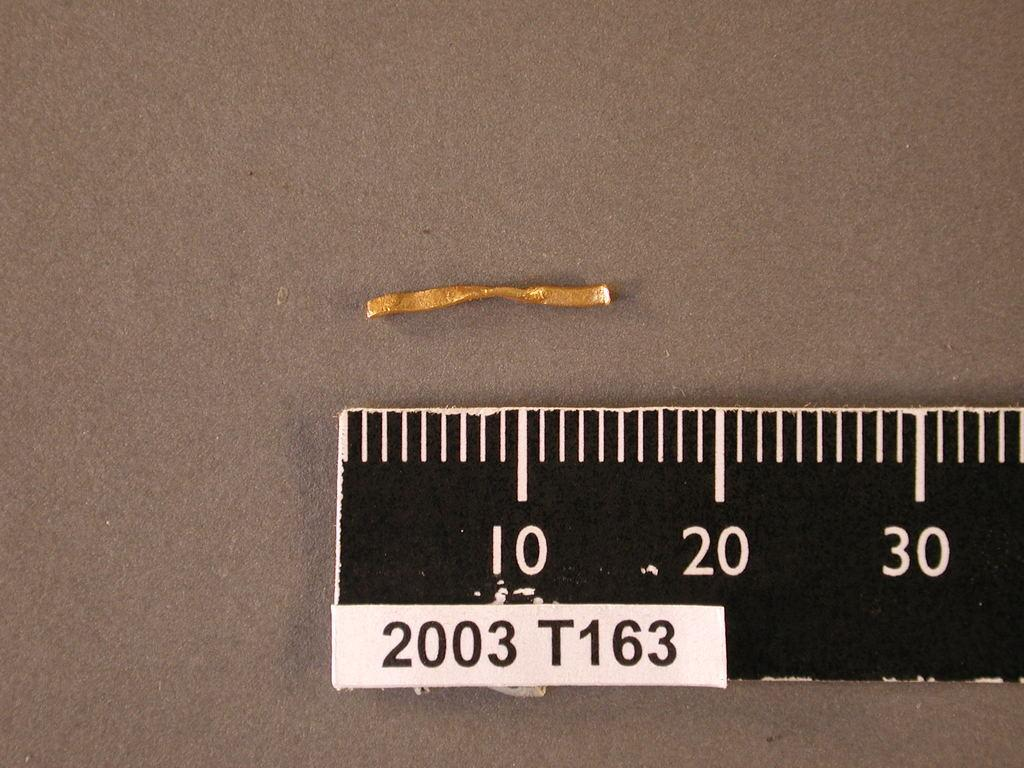<image>
Provide a brief description of the given image. a small piece of golden string sits in front of a ruler labeled T163 